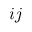<formula> <loc_0><loc_0><loc_500><loc_500>i j</formula> 